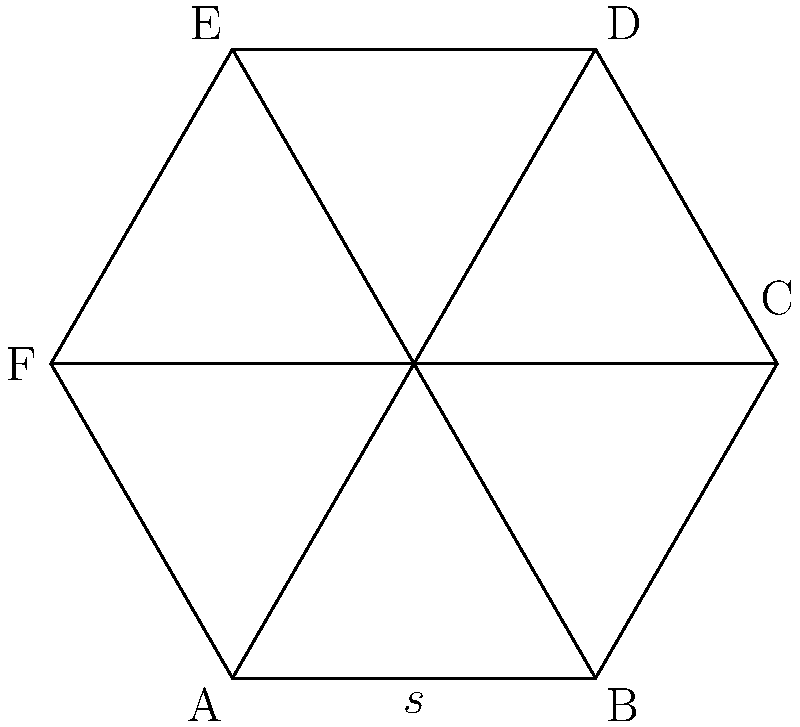A regular hexagon represents city blocks affected by cybercrime. If the side length of this hexagon is $s = 5$ km, what is the total perimeter of the affected area? To calculate the perimeter of a regular hexagon, we need to follow these steps:

1) A regular hexagon has 6 equal sides.

2) The perimeter of any polygon is the sum of the lengths of all its sides.

3) For a regular hexagon, this means:
   Perimeter $= 6 \times$ side length

4) We are given that the side length $s = 5$ km.

5) Therefore, the perimeter is:
   Perimeter $= 6 \times 5$ km $= 30$ km

This 30 km represents the total boundary length of the city blocks affected by cybercrime.
Answer: $30$ km 